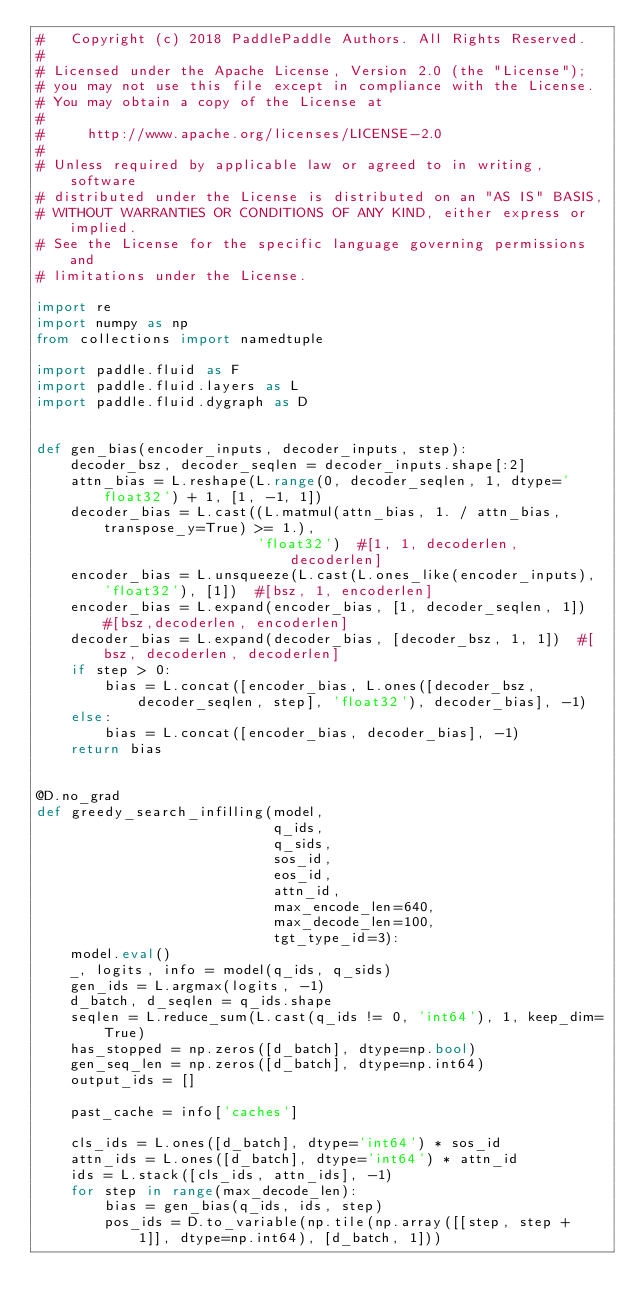Convert code to text. <code><loc_0><loc_0><loc_500><loc_500><_Python_>#   Copyright (c) 2018 PaddlePaddle Authors. All Rights Reserved.
#
# Licensed under the Apache License, Version 2.0 (the "License");
# you may not use this file except in compliance with the License.
# You may obtain a copy of the License at
#
#     http://www.apache.org/licenses/LICENSE-2.0
#
# Unless required by applicable law or agreed to in writing, software
# distributed under the License is distributed on an "AS IS" BASIS,
# WITHOUT WARRANTIES OR CONDITIONS OF ANY KIND, either express or implied.
# See the License for the specific language governing permissions and
# limitations under the License.

import re
import numpy as np
from collections import namedtuple

import paddle.fluid as F
import paddle.fluid.layers as L
import paddle.fluid.dygraph as D


def gen_bias(encoder_inputs, decoder_inputs, step):
    decoder_bsz, decoder_seqlen = decoder_inputs.shape[:2]
    attn_bias = L.reshape(L.range(0, decoder_seqlen, 1, dtype='float32') + 1, [1, -1, 1])
    decoder_bias = L.cast((L.matmul(attn_bias, 1. / attn_bias, transpose_y=True) >= 1.),
                          'float32')  #[1, 1, decoderlen, decoderlen]
    encoder_bias = L.unsqueeze(L.cast(L.ones_like(encoder_inputs), 'float32'), [1])  #[bsz, 1, encoderlen]
    encoder_bias = L.expand(encoder_bias, [1, decoder_seqlen, 1])  #[bsz,decoderlen, encoderlen]
    decoder_bias = L.expand(decoder_bias, [decoder_bsz, 1, 1])  #[bsz, decoderlen, decoderlen]
    if step > 0:
        bias = L.concat([encoder_bias, L.ones([decoder_bsz, decoder_seqlen, step], 'float32'), decoder_bias], -1)
    else:
        bias = L.concat([encoder_bias, decoder_bias], -1)
    return bias


@D.no_grad
def greedy_search_infilling(model,
                            q_ids,
                            q_sids,
                            sos_id,
                            eos_id,
                            attn_id,
                            max_encode_len=640,
                            max_decode_len=100,
                            tgt_type_id=3):
    model.eval()
    _, logits, info = model(q_ids, q_sids)
    gen_ids = L.argmax(logits, -1)
    d_batch, d_seqlen = q_ids.shape
    seqlen = L.reduce_sum(L.cast(q_ids != 0, 'int64'), 1, keep_dim=True)
    has_stopped = np.zeros([d_batch], dtype=np.bool)
    gen_seq_len = np.zeros([d_batch], dtype=np.int64)
    output_ids = []

    past_cache = info['caches']

    cls_ids = L.ones([d_batch], dtype='int64') * sos_id
    attn_ids = L.ones([d_batch], dtype='int64') * attn_id
    ids = L.stack([cls_ids, attn_ids], -1)
    for step in range(max_decode_len):
        bias = gen_bias(q_ids, ids, step)
        pos_ids = D.to_variable(np.tile(np.array([[step, step + 1]], dtype=np.int64), [d_batch, 1]))</code> 